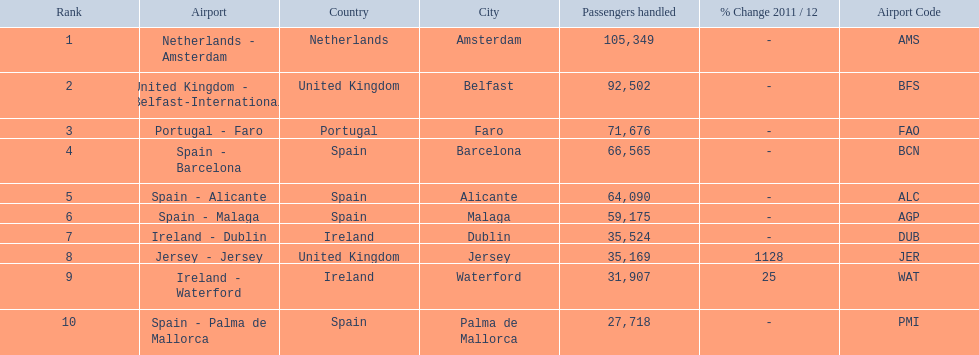What are all the passengers handled values for london southend airport? 105,349, 92,502, 71,676, 66,565, 64,090, 59,175, 35,524, 35,169, 31,907, 27,718. Could you parse the entire table? {'header': ['Rank', 'Airport', 'Country', 'City', 'Passengers handled', '% Change 2011 / 12', 'Airport Code'], 'rows': [['1', 'Netherlands - Amsterdam', 'Netherlands', 'Amsterdam', '105,349', '-', 'AMS'], ['2', 'United Kingdom - Belfast-International', 'United Kingdom', 'Belfast', '92,502', '-', 'BFS'], ['3', 'Portugal - Faro', 'Portugal', 'Faro', '71,676', '-', 'FAO'], ['4', 'Spain - Barcelona', 'Spain', 'Barcelona', '66,565', '-', 'BCN'], ['5', 'Spain - Alicante', 'Spain', 'Alicante', '64,090', '-', 'ALC'], ['6', 'Spain - Malaga', 'Spain', 'Malaga', '59,175', '-', 'AGP'], ['7', 'Ireland - Dublin', 'Ireland', 'Dublin', '35,524', '-', 'DUB'], ['8', 'Jersey - Jersey', 'United Kingdom', 'Jersey', '35,169', '1128', 'JER'], ['9', 'Ireland - Waterford', 'Ireland', 'Waterford', '31,907', '25', 'WAT'], ['10', 'Spain - Palma de Mallorca', 'Spain', 'Palma de Mallorca', '27,718', '-', 'PMI']]} Which are 30,000 or less? 27,718. What airport is this for? Spain - Palma de Mallorca. 